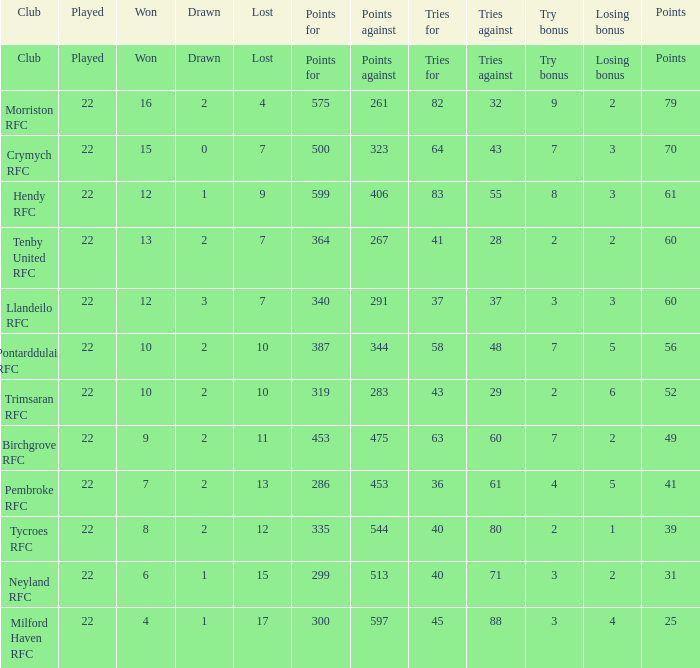What's the won with try bonus being 8 12.0. Give me the full table as a dictionary. {'header': ['Club', 'Played', 'Won', 'Drawn', 'Lost', 'Points for', 'Points against', 'Tries for', 'Tries against', 'Try bonus', 'Losing bonus', 'Points'], 'rows': [['Club', 'Played', 'Won', 'Drawn', 'Lost', 'Points for', 'Points against', 'Tries for', 'Tries against', 'Try bonus', 'Losing bonus', 'Points'], ['Morriston RFC', '22', '16', '2', '4', '575', '261', '82', '32', '9', '2', '79'], ['Crymych RFC', '22', '15', '0', '7', '500', '323', '64', '43', '7', '3', '70'], ['Hendy RFC', '22', '12', '1', '9', '599', '406', '83', '55', '8', '3', '61'], ['Tenby United RFC', '22', '13', '2', '7', '364', '267', '41', '28', '2', '2', '60'], ['Llandeilo RFC', '22', '12', '3', '7', '340', '291', '37', '37', '3', '3', '60'], ['Pontarddulais RFC', '22', '10', '2', '10', '387', '344', '58', '48', '7', '5', '56'], ['Trimsaran RFC', '22', '10', '2', '10', '319', '283', '43', '29', '2', '6', '52'], ['Birchgrove RFC', '22', '9', '2', '11', '453', '475', '63', '60', '7', '2', '49'], ['Pembroke RFC', '22', '7', '2', '13', '286', '453', '36', '61', '4', '5', '41'], ['Tycroes RFC', '22', '8', '2', '12', '335', '544', '40', '80', '2', '1', '39'], ['Neyland RFC', '22', '6', '1', '15', '299', '513', '40', '71', '3', '2', '31'], ['Milford Haven RFC', '22', '4', '1', '17', '300', '597', '45', '88', '3', '4', '25']]} 